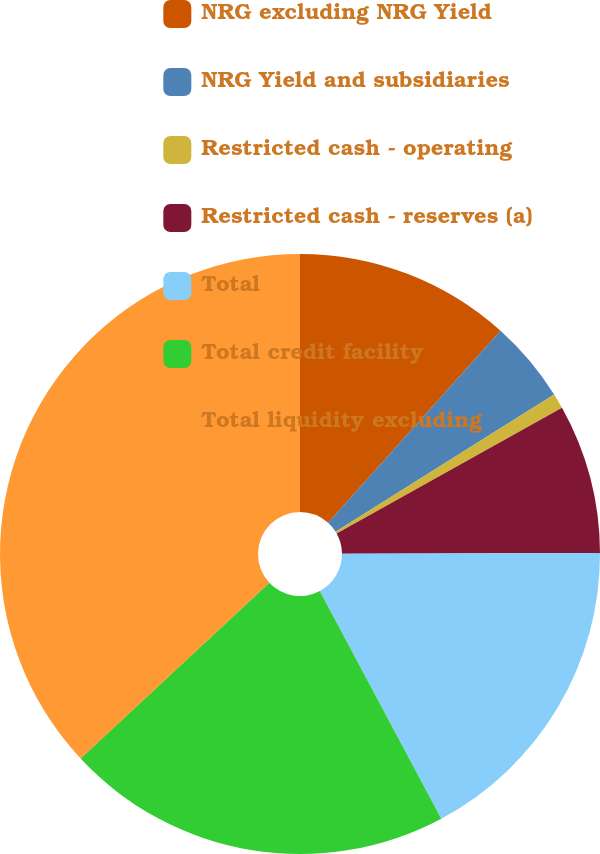Convert chart to OTSL. <chart><loc_0><loc_0><loc_500><loc_500><pie_chart><fcel>NRG excluding NRG Yield<fcel>NRG Yield and subsidiaries<fcel>Restricted cash - operating<fcel>Restricted cash - reserves (a)<fcel>Total<fcel>Total credit facility<fcel>Total liquidity excluding<nl><fcel>11.65%<fcel>4.43%<fcel>0.82%<fcel>8.04%<fcel>17.25%<fcel>20.86%<fcel>36.94%<nl></chart> 